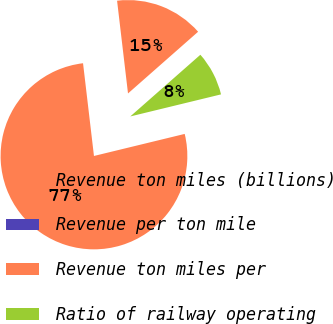Convert chart. <chart><loc_0><loc_0><loc_500><loc_500><pie_chart><fcel>Revenue ton miles (billions)<fcel>Revenue per ton mile<fcel>Revenue ton miles per<fcel>Ratio of railway operating<nl><fcel>15.38%<fcel>0.0%<fcel>76.92%<fcel>7.69%<nl></chart> 